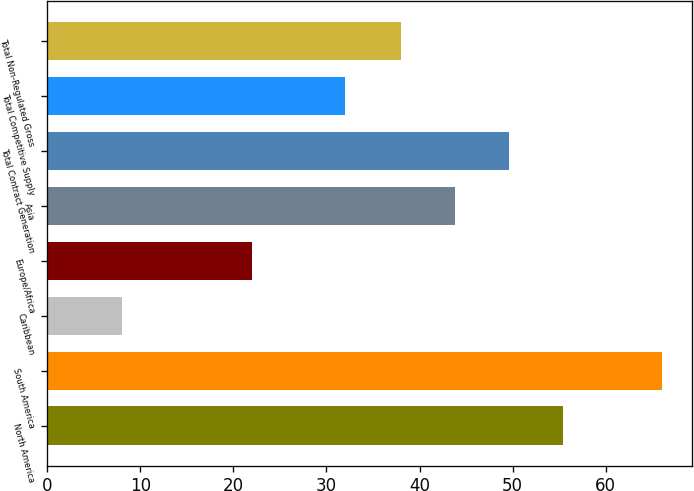Convert chart. <chart><loc_0><loc_0><loc_500><loc_500><bar_chart><fcel>North America<fcel>South America<fcel>Caribbean<fcel>Europe/Africa<fcel>Asia<fcel>Total Contract Generation<fcel>Total Competitive Supply<fcel>Total Non-Regulated Gross<nl><fcel>55.4<fcel>66<fcel>8<fcel>22<fcel>43.8<fcel>49.6<fcel>32<fcel>38<nl></chart> 